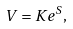Convert formula to latex. <formula><loc_0><loc_0><loc_500><loc_500>V = K e ^ { S } ,</formula> 